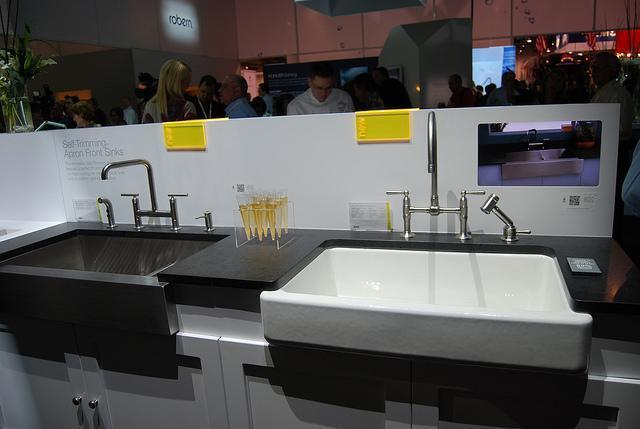What is found in the room?
Indicate the correct choice and explain in the format: 'Answer: answer
Rationale: rationale.'
Options: Car, sink, hammer, snake. Answer: sink.
Rationale: There are two of them with faucets 